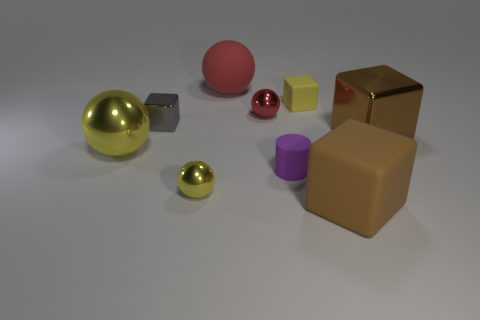There is a tiny block that is the same color as the large metallic sphere; what is it made of?
Make the answer very short. Rubber. There is a rubber ball; does it have the same color as the tiny ball behind the tiny purple cylinder?
Keep it short and to the point. Yes. The tiny object that is both in front of the gray object and to the left of the rubber sphere has what shape?
Ensure brevity in your answer.  Sphere. There is a red object that is behind the small red thing; does it have the same size as the metallic block that is to the left of the yellow cube?
Your answer should be very brief. No. The small purple object that is made of the same material as the yellow cube is what shape?
Give a very brief answer. Cylinder. Is there anything else that is the same shape as the tiny purple thing?
Your answer should be compact. No. There is a big metal object that is to the right of the brown cube that is left of the thing that is to the right of the large brown rubber thing; what color is it?
Keep it short and to the point. Brown. Are there fewer big metal blocks that are behind the large brown metal cube than big yellow metallic objects on the right side of the large red rubber thing?
Your response must be concise. No. Do the big brown matte object and the large yellow thing have the same shape?
Your answer should be very brief. No. What number of yellow things have the same size as the purple rubber cylinder?
Offer a terse response. 2. 